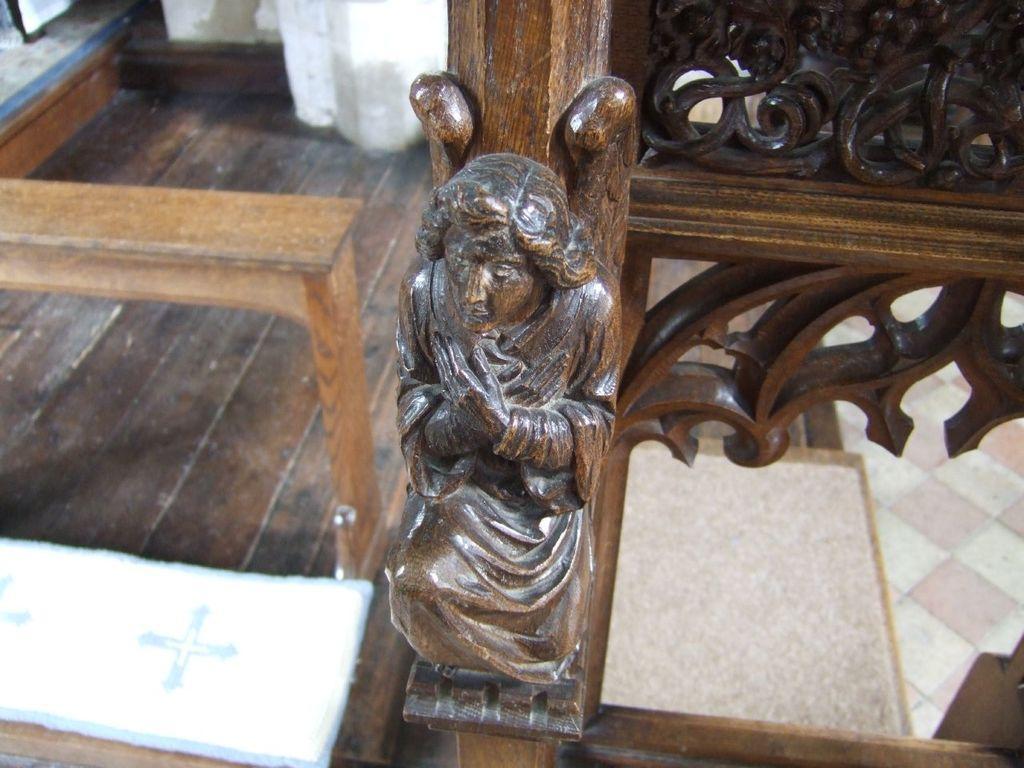How would you summarize this image in a sentence or two? In the foreground of the picture there are wooden sculptures and bench. On the right it is floor. At the top it is well. 